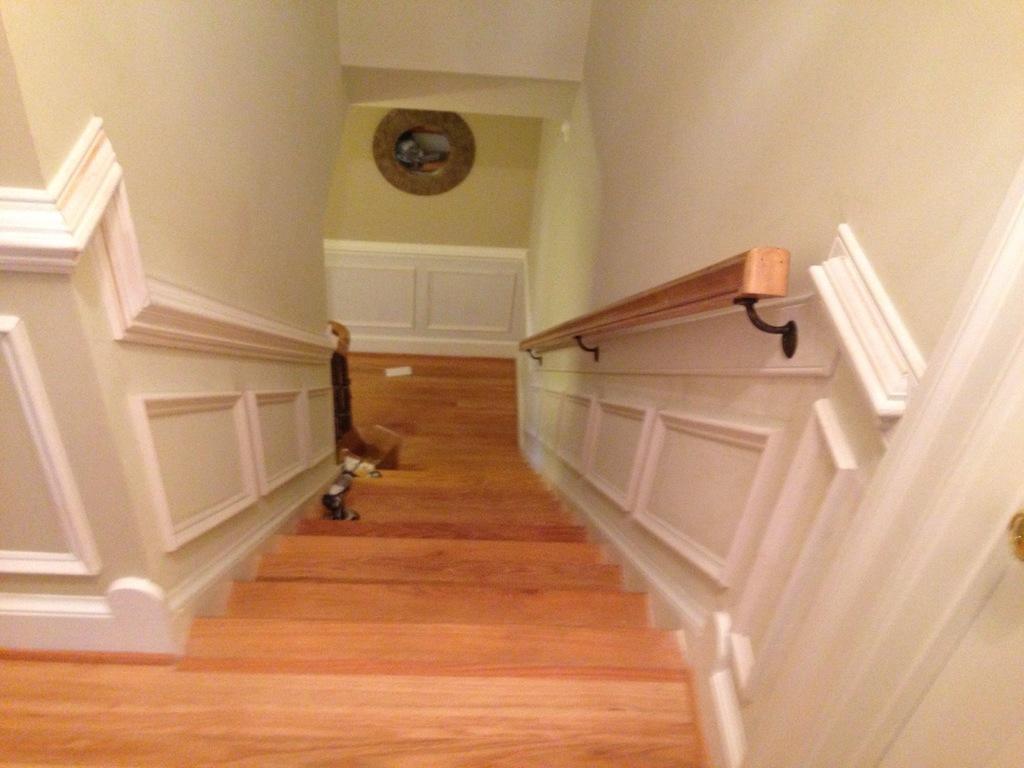In one or two sentences, can you explain what this image depicts? In this image I can see stairs in the centre and on it I can see few stuffs. 